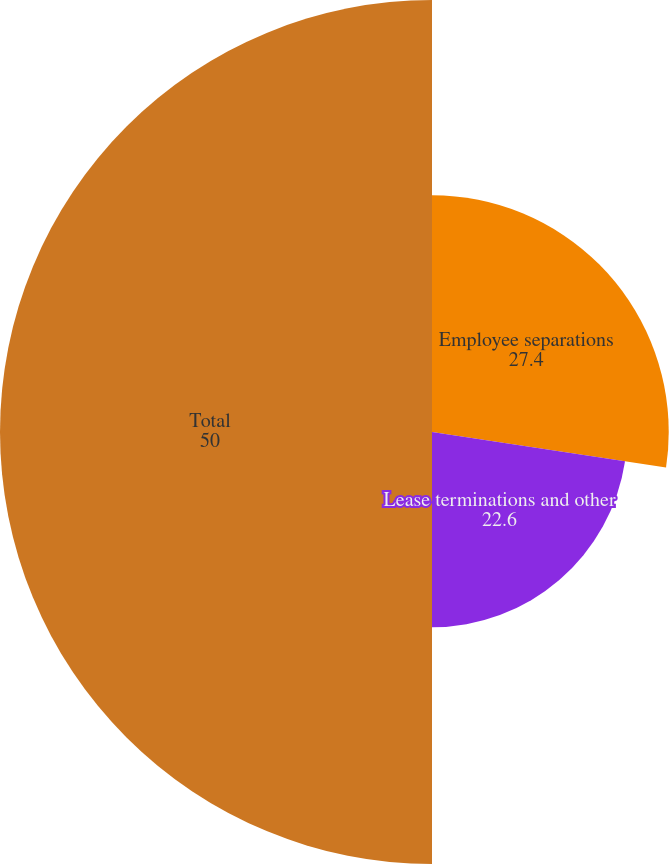<chart> <loc_0><loc_0><loc_500><loc_500><pie_chart><fcel>Employee separations<fcel>Lease terminations and other<fcel>Total<nl><fcel>27.4%<fcel>22.6%<fcel>50.0%<nl></chart> 